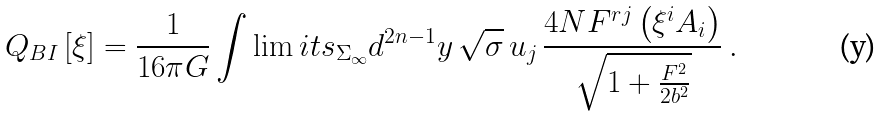Convert formula to latex. <formula><loc_0><loc_0><loc_500><loc_500>Q _ { B I } \left [ \xi \right ] = \frac { 1 } { 1 6 \pi G } \int \lim i t s _ { \Sigma _ { \infty } } d ^ { 2 n - 1 } y \, \sqrt { \sigma } \, u _ { j } \, \frac { 4 N F ^ { r j } \left ( \xi ^ { i } A _ { i } \right ) } { \sqrt { 1 + \frac { F ^ { 2 } } { 2 b ^ { 2 } } } } \, .</formula> 